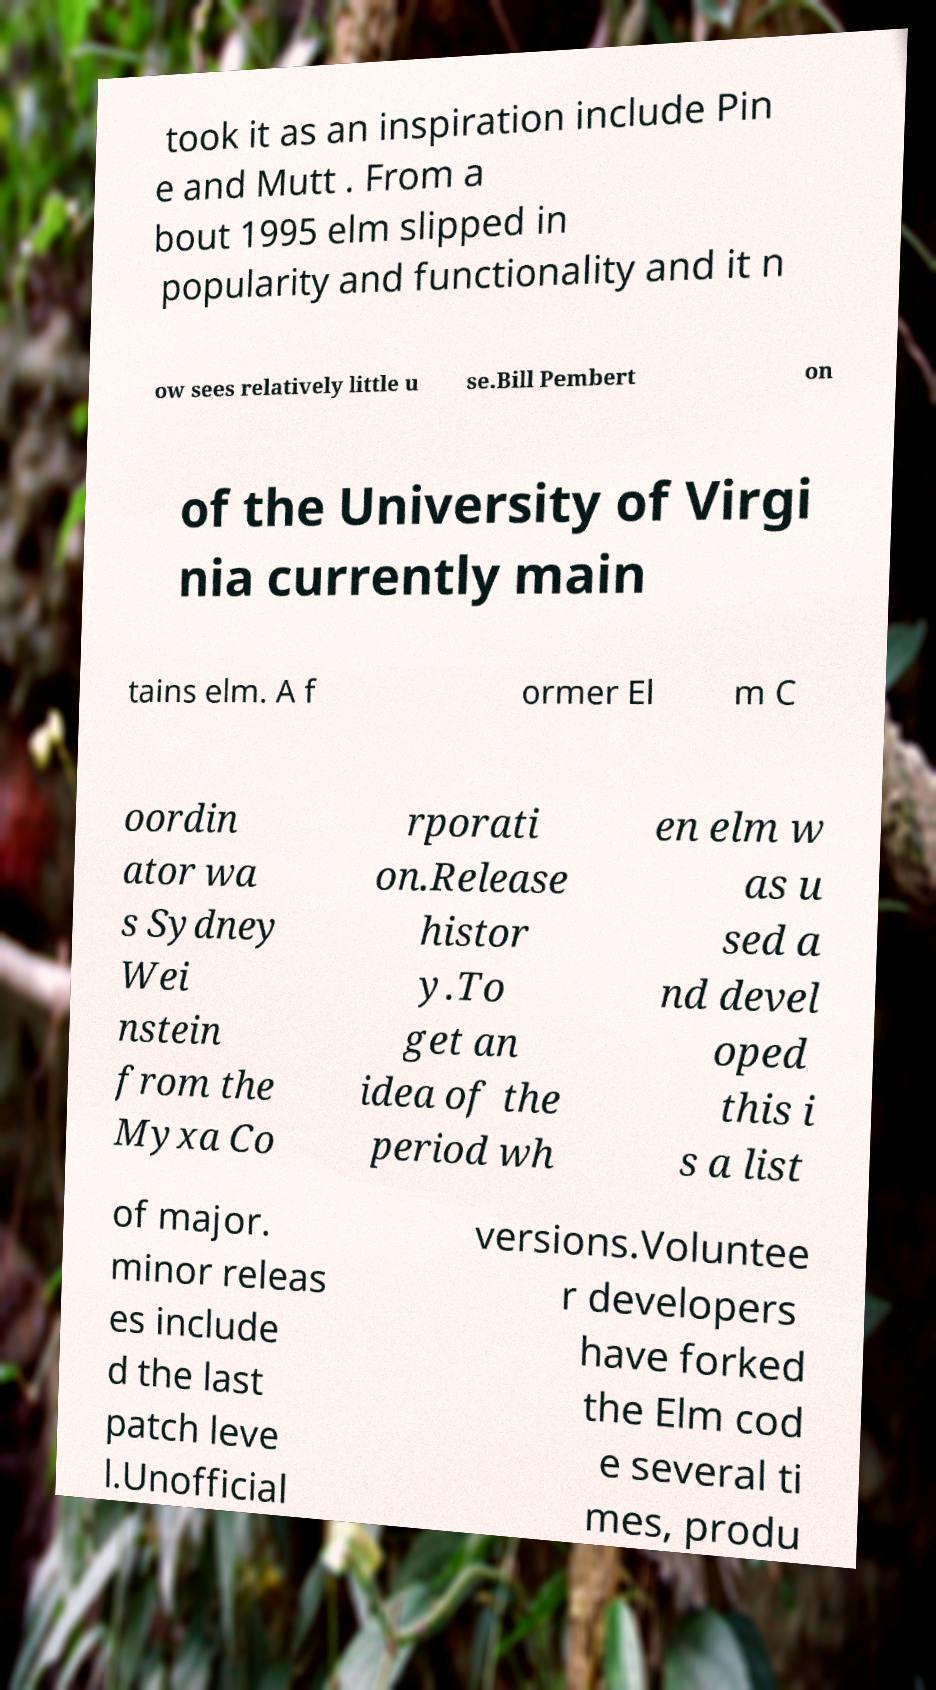For documentation purposes, I need the text within this image transcribed. Could you provide that? took it as an inspiration include Pin e and Mutt . From a bout 1995 elm slipped in popularity and functionality and it n ow sees relatively little u se.Bill Pembert on of the University of Virgi nia currently main tains elm. A f ormer El m C oordin ator wa s Sydney Wei nstein from the Myxa Co rporati on.Release histor y.To get an idea of the period wh en elm w as u sed a nd devel oped this i s a list of major. minor releas es include d the last patch leve l.Unofficial versions.Voluntee r developers have forked the Elm cod e several ti mes, produ 